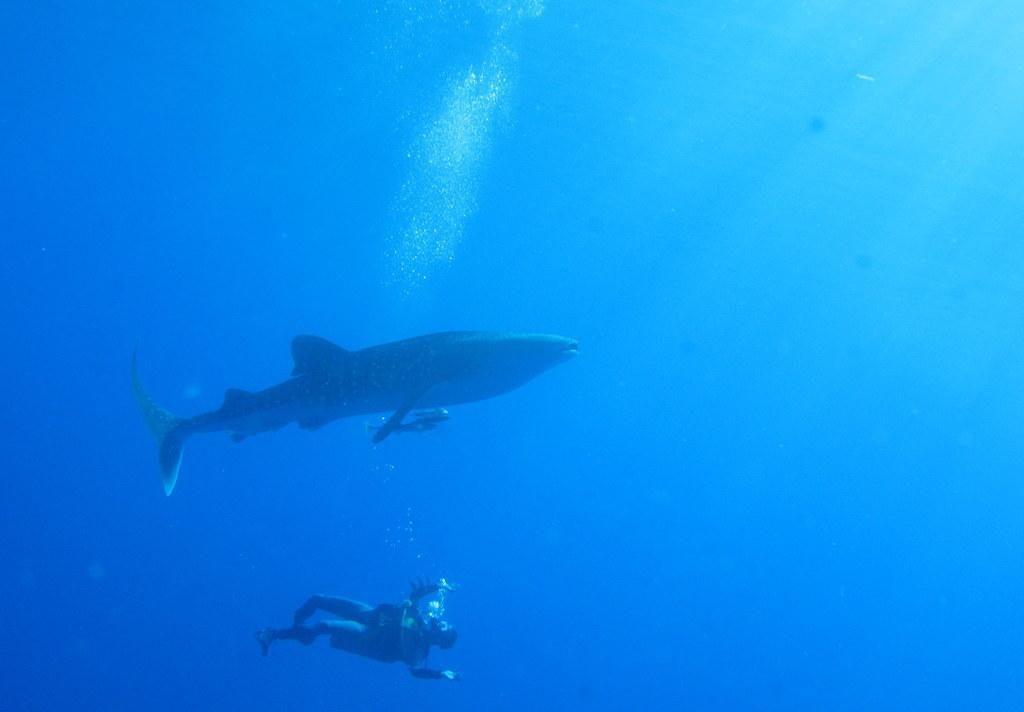What is present in the image that is not solid? There is water in the image. What type of animal can be seen in the image? There is a whale in the image. What is the man in the image doing? The man is in the water. What color is the background of the image? The background of the image is blue in color. Is there a volcano erupting in the background of the image? No, there is no volcano present in the image. How does the man in the water manage to avoid getting burned by the whale? There is no indication in the image that the man is in danger of being burned by the whale, as whales do not produce heat or flames. 